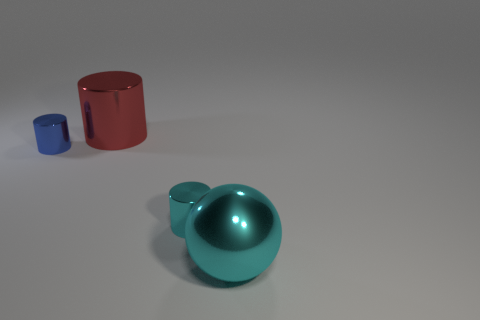Are there fewer large purple metal cylinders than things? Based on the image, there is one large red cylinder and one smaller blue cylinder along with a large teal sphere. In total, there are three distinct objects, and since we are only talking about cylinders, there are fewer large purple metal cylinders than things overall. 